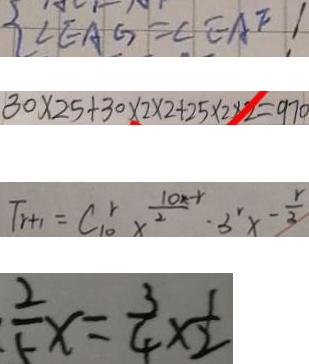<formula> <loc_0><loc_0><loc_500><loc_500>\angle E A G = \angle E A F 1 
 3 0 \times 2 5 + 3 0 \times 2 \times 2 + 2 5 \times 2 \times 2 = 9 7 0 
 T _ { r + 1 } = C _ { 1 0 } ^ { r } x ^ { \frac { 1 0 x - r } { 2 } } \cdot 3 ^ { r } x - \frac { r } { 3 } 
 \frac { 2 } { 5 } x = \frac { 3 } { 4 } \times \frac { 1 } { 2 }</formula> 